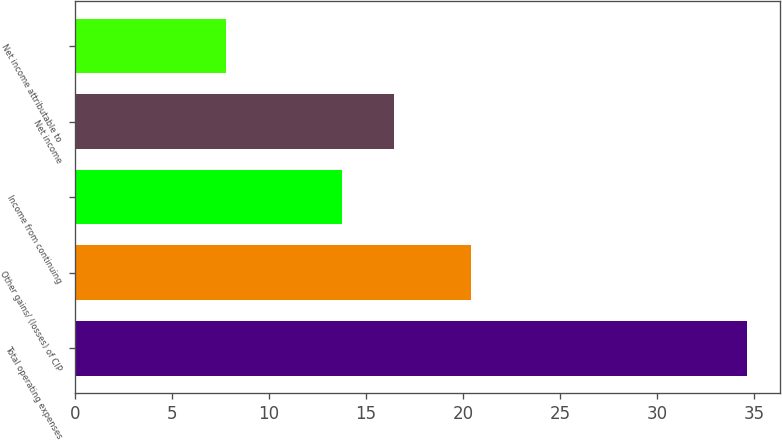Convert chart to OTSL. <chart><loc_0><loc_0><loc_500><loc_500><bar_chart><fcel>Total operating expenses<fcel>Other gains/ (losses) of CIP<fcel>Income from continuing<fcel>Net income<fcel>Net income attributable to<nl><fcel>34.6<fcel>20.4<fcel>13.78<fcel>16.46<fcel>7.8<nl></chart> 